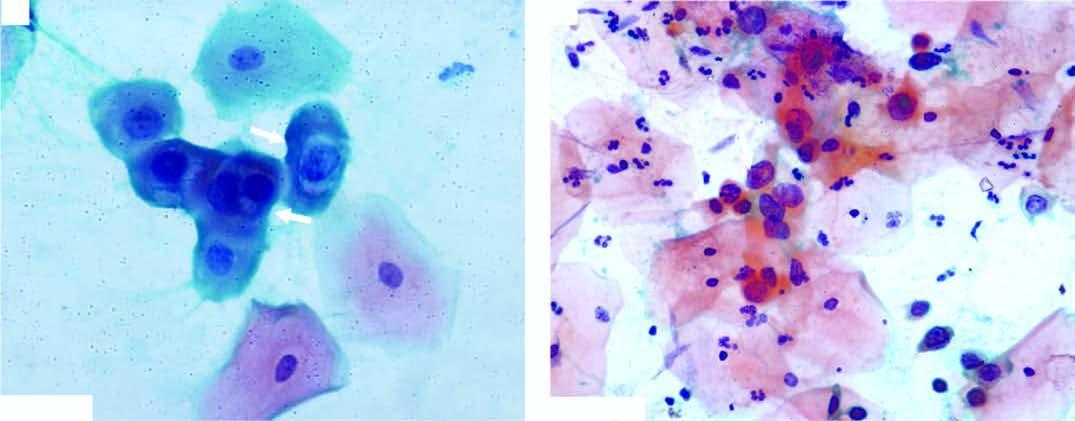what have scanty cytoplasm and markedly hyperchromatic nuclei having irregular nuclear outlines?
Answer the question using a single word or phrase. Squamous cells 